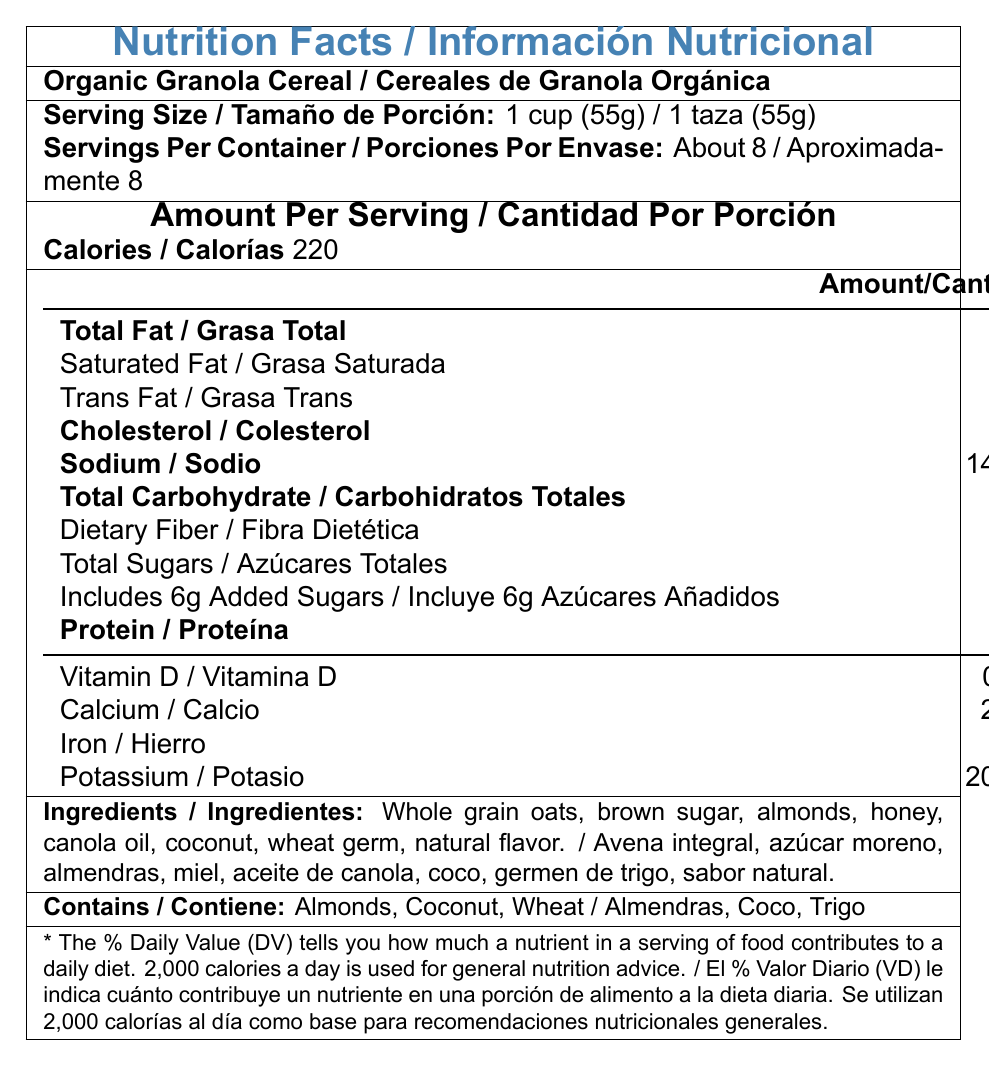what is the product name in the host language? The product name listed in the host language (Spanish) is "Cereales de Granola Orgánica".
Answer: Cereales de Granola Orgánica How many servings are there per container? The label states that there are about 8 servings per container.
Answer: About 8 What is the serving size in grams? The document specifies a serving size of 1 cup, which is equivalent to 55 grams.
Answer: 55g How much Total Fat is in one serving? The document lists the Total Fat content per serving as 9 grams.
Answer: 9g What percentage of the daily value does Dietary Fiber contribute? According to the document, Dietary Fiber contributes 14% of the daily value per serving.
Answer: 14% How many grams of Protein are there per serving? The document states that there are 6 grams of Protein per serving.
Answer: 6g How much sodium is in one serving? A. 100mg B. 140mg C. 200mg The document lists 140mg of sodium per serving.
Answer: B. 140mg Which of the following minerals is present in the highest amount per serving? A. Calcium B. Iron C. Potassium Potassium is present at 200mg per serving, Calcium at 20mg, and Iron at 2mg, making Potassium the highest.
Answer: C. Potassium Is there any Trans Fat in this product? The document indicates that there is 0g of Trans Fat per serving.
Answer: No Summarize the main nutritional information provided for this product. This summary covers the primary details regarding serving size and nutrient content per serving, as well as mentioning the ingredients and allergens.
Answer: The Nutrition Facts label for Organic Granola Cereal (Cereales de Granola Orgánica) provides detailed information about the serving size (1 cup or 55g), number of servings per container (about 8), and the amount of various nutrients in each serving, including calories (220), Total Fat (9g), Saturated Fat (1g), Trans Fat (0g), Cholesterol (0mg), Sodium (140mg), Total Carbohydrate (31g), Dietary Fiber (4g), Total Sugars (9g), Added Sugars (6g), Protein (6g), Vitamin D (0mcg), Calcium (20mg), Iron (2mg), and Potassium (200mg). It also lists the ingredients and allergen statement. What is the amount of Vitamin D in one serving? The document states that there is 0mcg of Vitamin D per serving.
Answer: 0mcg What’s the percentage daily value of Sodium provided by one serving? The document indicates that one serving provides 6% of the daily value of Sodium.
Answer: 6% How many grams of added sugars are included in one serving? The label mentions that each serving includes 6g of added sugars.
Answer: 6g What are the first three ingredients listed in the host language? A. Avena integral, azúcar moreno, almendras B. Avena integral, almendras, miel C. Azúcar moreno, almendras, miel According to the ingredients list in the host language, the first three ingredients are "Avena integral, azúcar moreno, almendras".
Answer: A. Avena integral, azúcar moreno, almendras What is the % DV of Iron per serving? The document states that the Iron content per serving is 2mg, contributing 10% of the daily value.
Answer: 10% Does the product contain any allergens? The allergen statement on the label indicates that the product contains Almonds, Coconut, and Wheat.
Answer: Yes What is the daily value disclaimer in the host language? The document includes a daily value disclaimer in the host language, explaining how the % DV is calculated based on a 2,000-calorie diet.
Answer: * El % Valor Diario (VD) le indica cuánto contribuye un nutriente en una porción de alimento a la dieta diaria. Se utilizan 2,000 calorías al día como base para recomendaciones nutricionales generales. What is the source of the natural flavor listed in the ingredients? The document lists "natural flavor" in the ingredients but does not specify the source.
Answer: Not enough information 